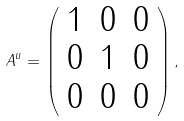Convert formula to latex. <formula><loc_0><loc_0><loc_500><loc_500>A ^ { u } = \left ( \begin{array} { c c c } 1 & 0 & 0 \\ 0 & 1 & 0 \\ 0 & 0 & 0 \end{array} \right ) ,</formula> 